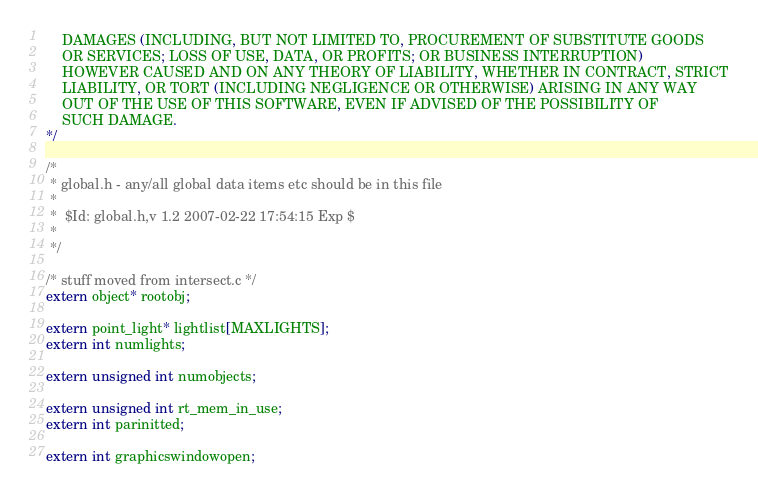Convert code to text. <code><loc_0><loc_0><loc_500><loc_500><_C++_>    DAMAGES (INCLUDING, BUT NOT LIMITED TO, PROCUREMENT OF SUBSTITUTE GOODS
    OR SERVICES; LOSS OF USE, DATA, OR PROFITS; OR BUSINESS INTERRUPTION)
    HOWEVER CAUSED AND ON ANY THEORY OF LIABILITY, WHETHER IN CONTRACT, STRICT
    LIABILITY, OR TORT (INCLUDING NEGLIGENCE OR OTHERWISE) ARISING IN ANY WAY
    OUT OF THE USE OF THIS SOFTWARE, EVEN IF ADVISED OF THE POSSIBILITY OF
    SUCH DAMAGE.
*/

/*
 * global.h - any/all global data items etc should be in this file
 *
 *  $Id: global.h,v 1.2 2007-02-22 17:54:15 Exp $
 *
 */

/* stuff moved from intersect.c */
extern object* rootobj;

extern point_light* lightlist[MAXLIGHTS];
extern int numlights;

extern unsigned int numobjects;

extern unsigned int rt_mem_in_use;
extern int parinitted;

extern int graphicswindowopen;
</code> 